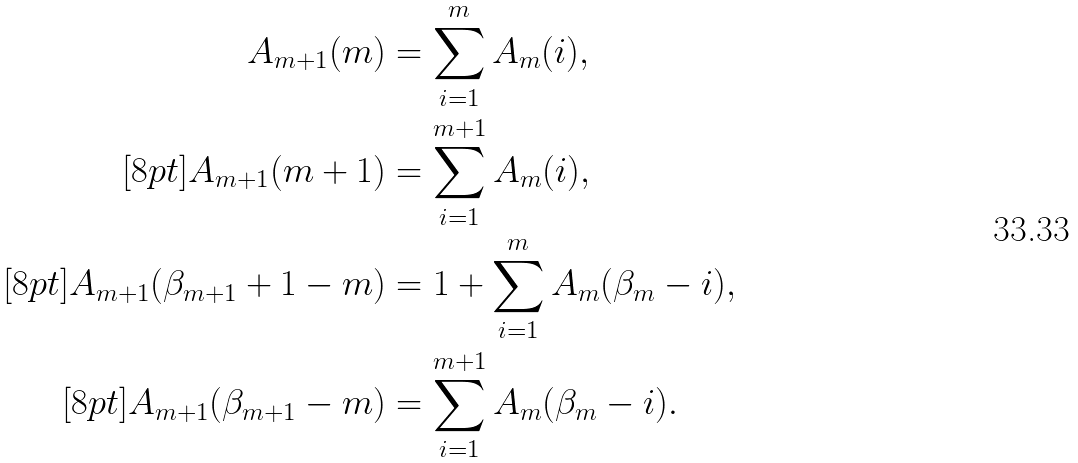Convert formula to latex. <formula><loc_0><loc_0><loc_500><loc_500>A _ { m + 1 } ( m ) & = \sum _ { i = 1 } ^ { m } A _ { m } ( i ) , \\ [ 8 p t ] A _ { m + 1 } ( m + 1 ) & = \sum _ { i = 1 } ^ { m + 1 } A _ { m } ( i ) , \\ [ 8 p t ] A _ { m + 1 } ( \beta _ { m + 1 } + 1 - m ) & = 1 + \sum _ { i = 1 } ^ { m } A _ { m } ( \beta _ { m } - i ) , \\ [ 8 p t ] A _ { m + 1 } ( \beta _ { m + 1 } - m ) & = \sum _ { i = 1 } ^ { m + 1 } A _ { m } ( \beta _ { m } - i ) .</formula> 